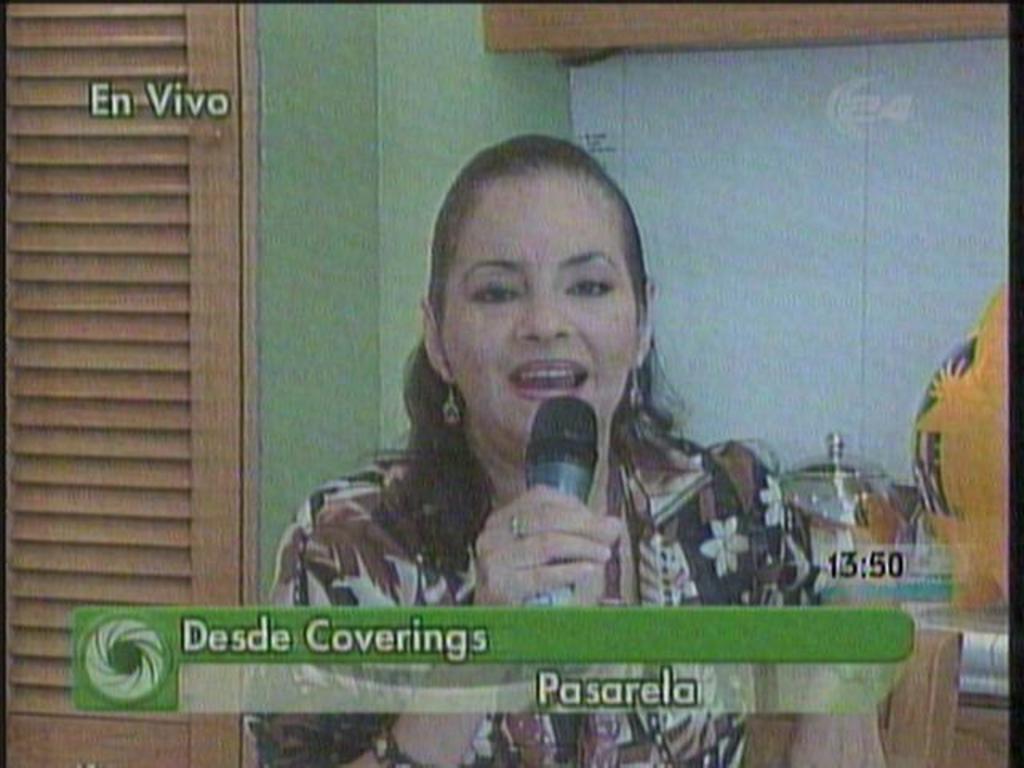Describe this image in one or two sentences. In this picture there is a woman sitting and holding the microphone and she is talking. At the back there are utensils on the table and there is a cupboard. At the bottom there is text. 